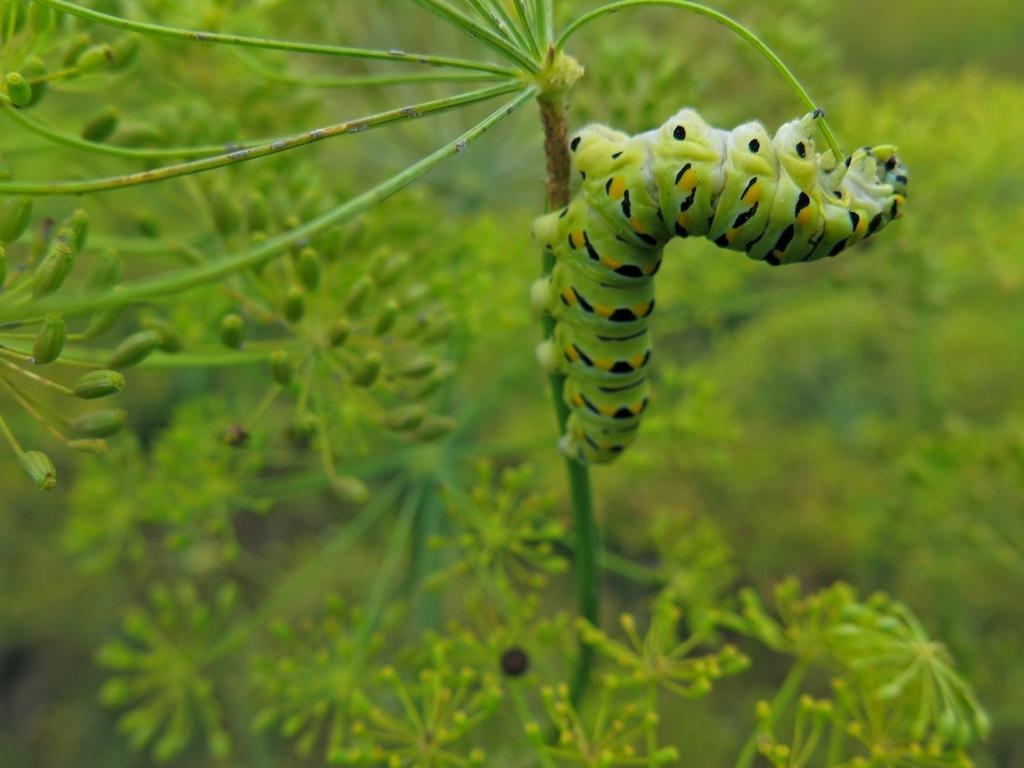What type of creature is in the image? There is an insect in the image. Where is the insect located? The insect is on a stem. What can be seen in the background of the image? There are plants in the background of the image. What is the insect talking about with the seashore in the image? There is no seashore present in the image, and insects do not talk. 